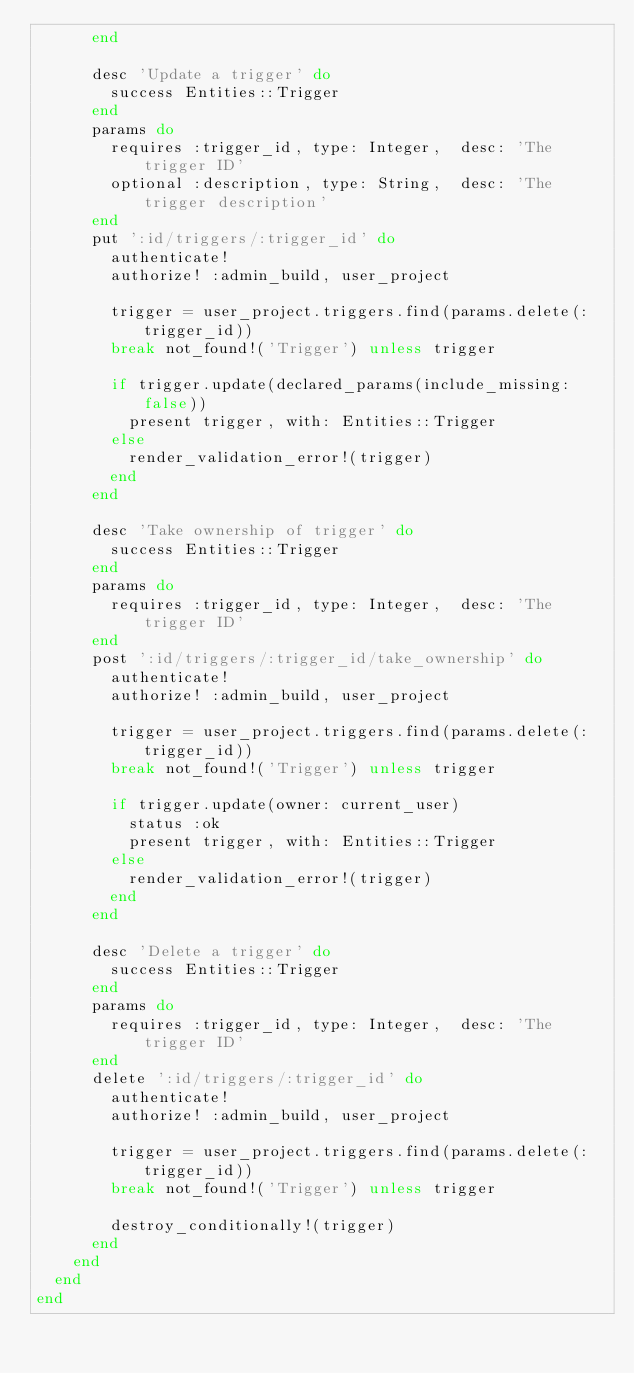Convert code to text. <code><loc_0><loc_0><loc_500><loc_500><_Ruby_>      end

      desc 'Update a trigger' do
        success Entities::Trigger
      end
      params do
        requires :trigger_id, type: Integer,  desc: 'The trigger ID'
        optional :description, type: String,  desc: 'The trigger description'
      end
      put ':id/triggers/:trigger_id' do
        authenticate!
        authorize! :admin_build, user_project

        trigger = user_project.triggers.find(params.delete(:trigger_id))
        break not_found!('Trigger') unless trigger

        if trigger.update(declared_params(include_missing: false))
          present trigger, with: Entities::Trigger
        else
          render_validation_error!(trigger)
        end
      end

      desc 'Take ownership of trigger' do
        success Entities::Trigger
      end
      params do
        requires :trigger_id, type: Integer,  desc: 'The trigger ID'
      end
      post ':id/triggers/:trigger_id/take_ownership' do
        authenticate!
        authorize! :admin_build, user_project

        trigger = user_project.triggers.find(params.delete(:trigger_id))
        break not_found!('Trigger') unless trigger

        if trigger.update(owner: current_user)
          status :ok
          present trigger, with: Entities::Trigger
        else
          render_validation_error!(trigger)
        end
      end

      desc 'Delete a trigger' do
        success Entities::Trigger
      end
      params do
        requires :trigger_id, type: Integer,  desc: 'The trigger ID'
      end
      delete ':id/triggers/:trigger_id' do
        authenticate!
        authorize! :admin_build, user_project

        trigger = user_project.triggers.find(params.delete(:trigger_id))
        break not_found!('Trigger') unless trigger

        destroy_conditionally!(trigger)
      end
    end
  end
end
</code> 